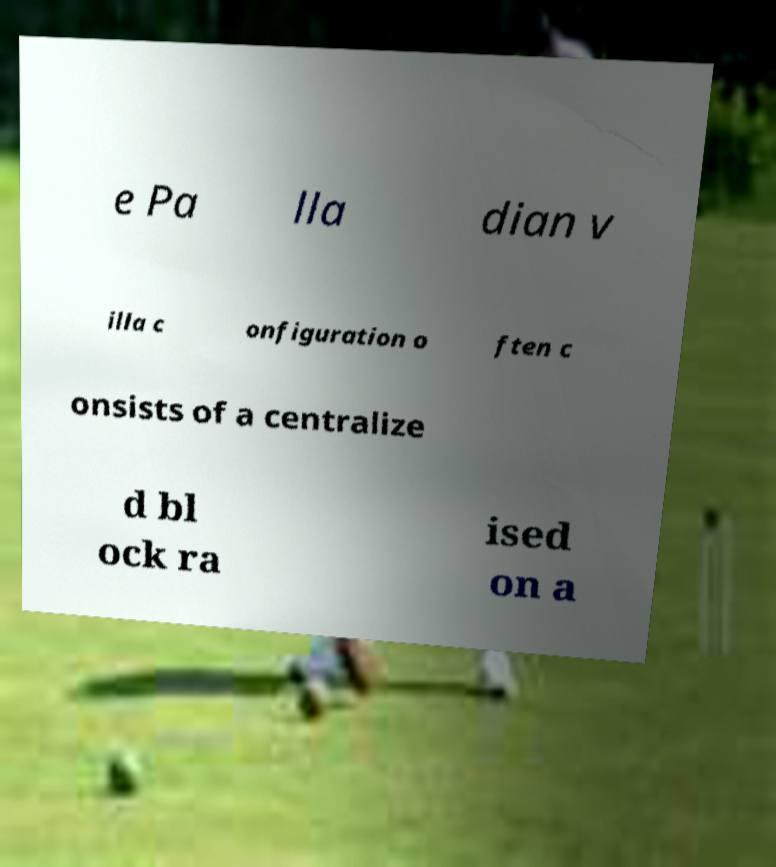For documentation purposes, I need the text within this image transcribed. Could you provide that? e Pa lla dian v illa c onfiguration o ften c onsists of a centralize d bl ock ra ised on a 